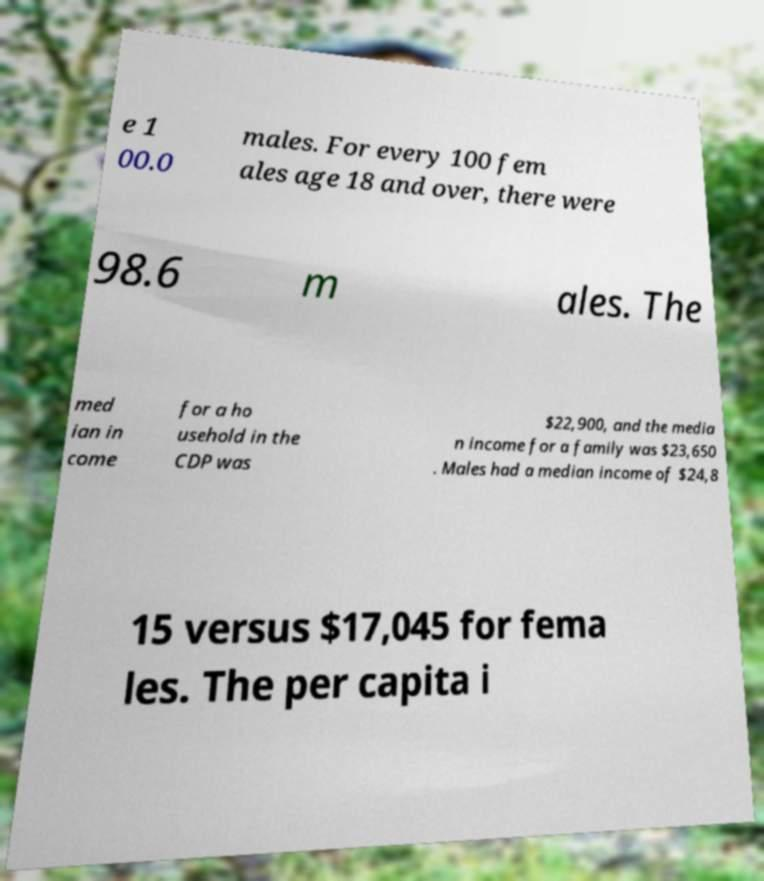For documentation purposes, I need the text within this image transcribed. Could you provide that? e 1 00.0 males. For every 100 fem ales age 18 and over, there were 98.6 m ales. The med ian in come for a ho usehold in the CDP was $22,900, and the media n income for a family was $23,650 . Males had a median income of $24,8 15 versus $17,045 for fema les. The per capita i 